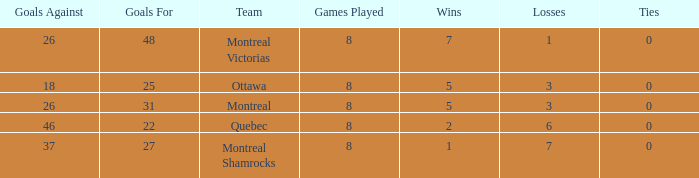For teams with 7 wins, what is the number of goals against? 26.0. 